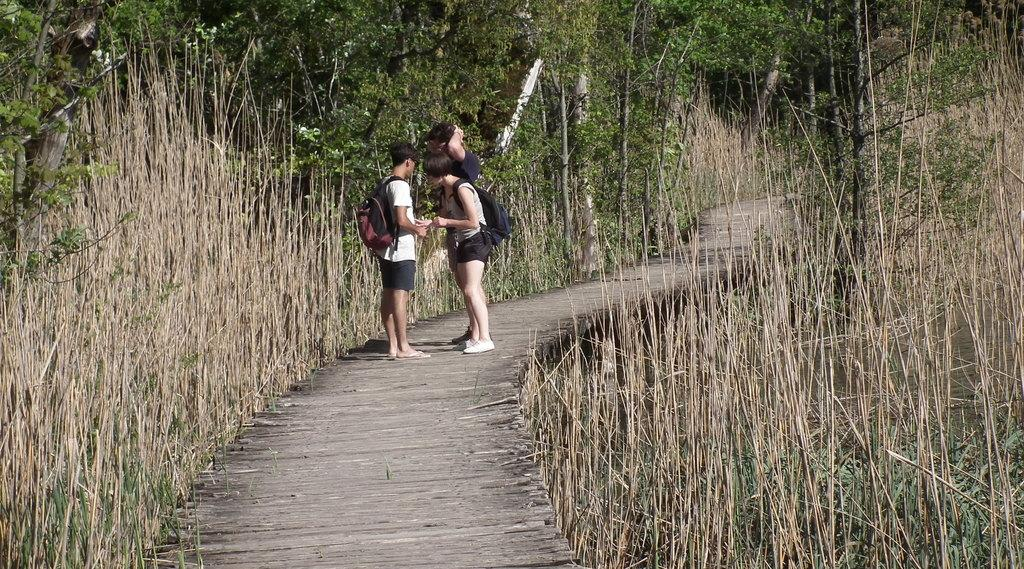How many people are present in the image? There are three persons in the image. What type of natural environment is visible in the image? There is grass visible in the image. What can be seen in the background of the image? There are trees in the background of the image. What type of hook is being used by the person in the image? There is no hook present in the image. What event is being celebrated by the three persons in the image? The image does not provide any information about an event being celebrated. 